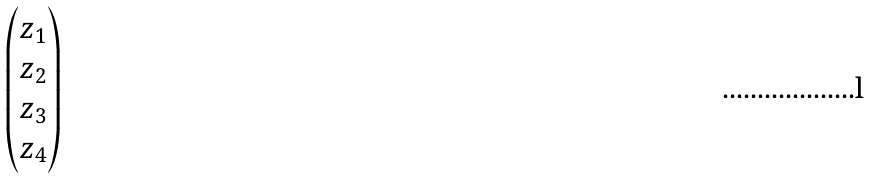Convert formula to latex. <formula><loc_0><loc_0><loc_500><loc_500>\begin{pmatrix} z _ { 1 } \\ z _ { 2 } \\ z _ { 3 } \\ z _ { 4 } \\ \end{pmatrix}</formula> 